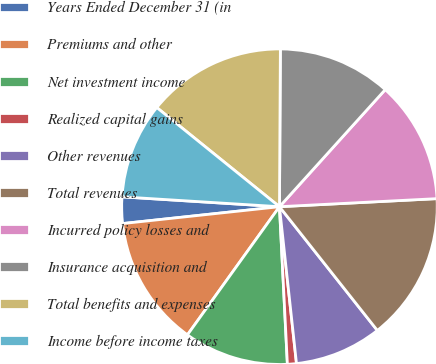Convert chart. <chart><loc_0><loc_0><loc_500><loc_500><pie_chart><fcel>Years Ended December 31 (in<fcel>Premiums and other<fcel>Net investment income<fcel>Realized capital gains<fcel>Other revenues<fcel>Total revenues<fcel>Incurred policy losses and<fcel>Insurance acquisition and<fcel>Total benefits and expenses<fcel>Income before income taxes<nl><fcel>2.7%<fcel>13.38%<fcel>10.71%<fcel>0.92%<fcel>8.93%<fcel>15.16%<fcel>12.49%<fcel>11.6%<fcel>14.27%<fcel>9.82%<nl></chart> 